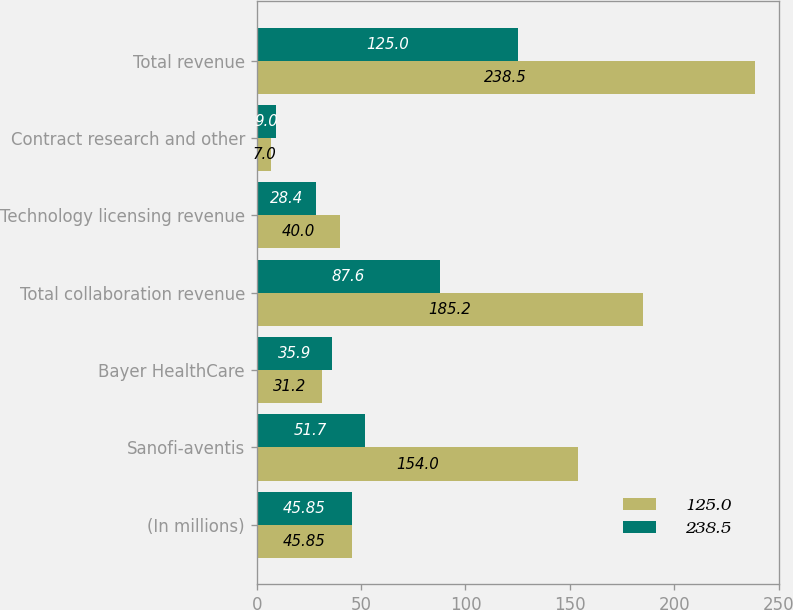Convert chart. <chart><loc_0><loc_0><loc_500><loc_500><stacked_bar_chart><ecel><fcel>(In millions)<fcel>Sanofi-aventis<fcel>Bayer HealthCare<fcel>Total collaboration revenue<fcel>Technology licensing revenue<fcel>Contract research and other<fcel>Total revenue<nl><fcel>125<fcel>45.85<fcel>154<fcel>31.2<fcel>185.2<fcel>40<fcel>7<fcel>238.5<nl><fcel>238.5<fcel>45.85<fcel>51.7<fcel>35.9<fcel>87.6<fcel>28.4<fcel>9<fcel>125<nl></chart> 